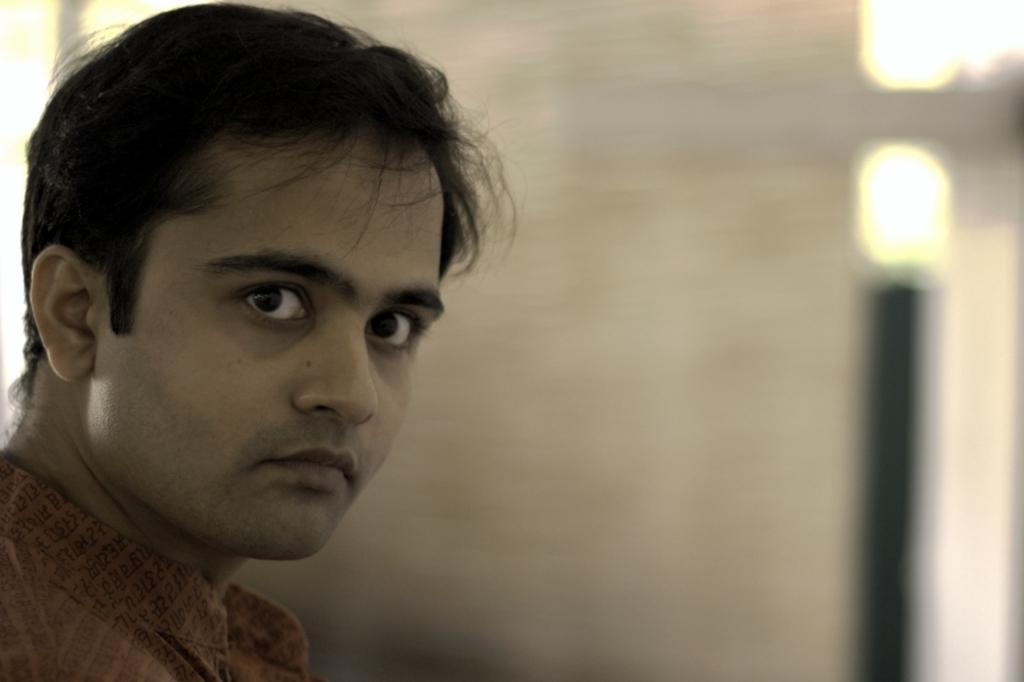Who is present in the image? There is a man in the image. What can be seen in the top right corner of the image? There are lights in the right side top corner of the image. Where is the nest located in the image? There is no nest present in the image. How does the man walk in the image? The image does not show the man walking; it only shows him standing or posing. 